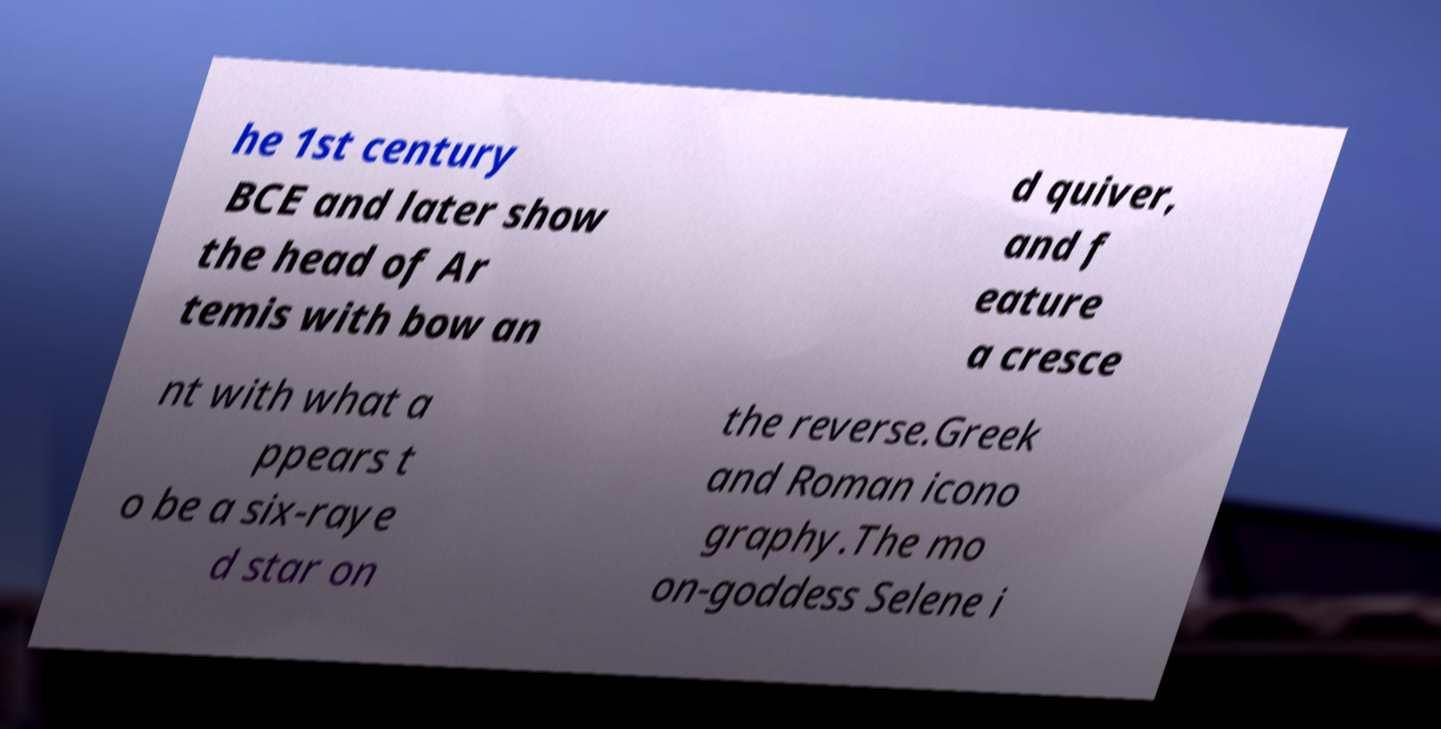I need the written content from this picture converted into text. Can you do that? he 1st century BCE and later show the head of Ar temis with bow an d quiver, and f eature a cresce nt with what a ppears t o be a six-raye d star on the reverse.Greek and Roman icono graphy.The mo on-goddess Selene i 